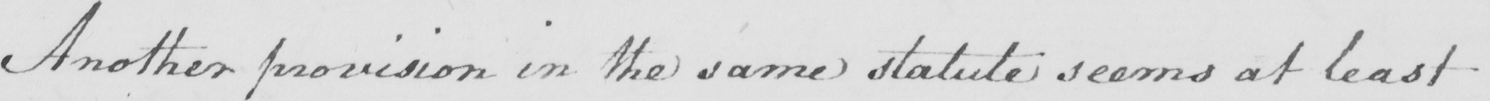What is written in this line of handwriting? Another provision in the same statute seems at least 